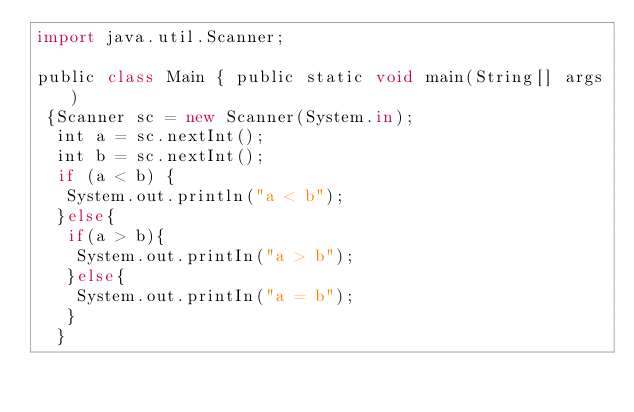<code> <loc_0><loc_0><loc_500><loc_500><_JavaScript_>import java.util.Scanner;

public class Main { public static void main(String[] args)
 {Scanner sc = new Scanner(System.in);
  int a = sc.nextInt();
  int b = sc.nextInt();
  if (a < b) {
   System.out.println("a < b");
  }else{
   if(a > b){
    System.out.printIn("a > b");
   }else{
    System.out.printIn("a = b");
   }
  }</code> 